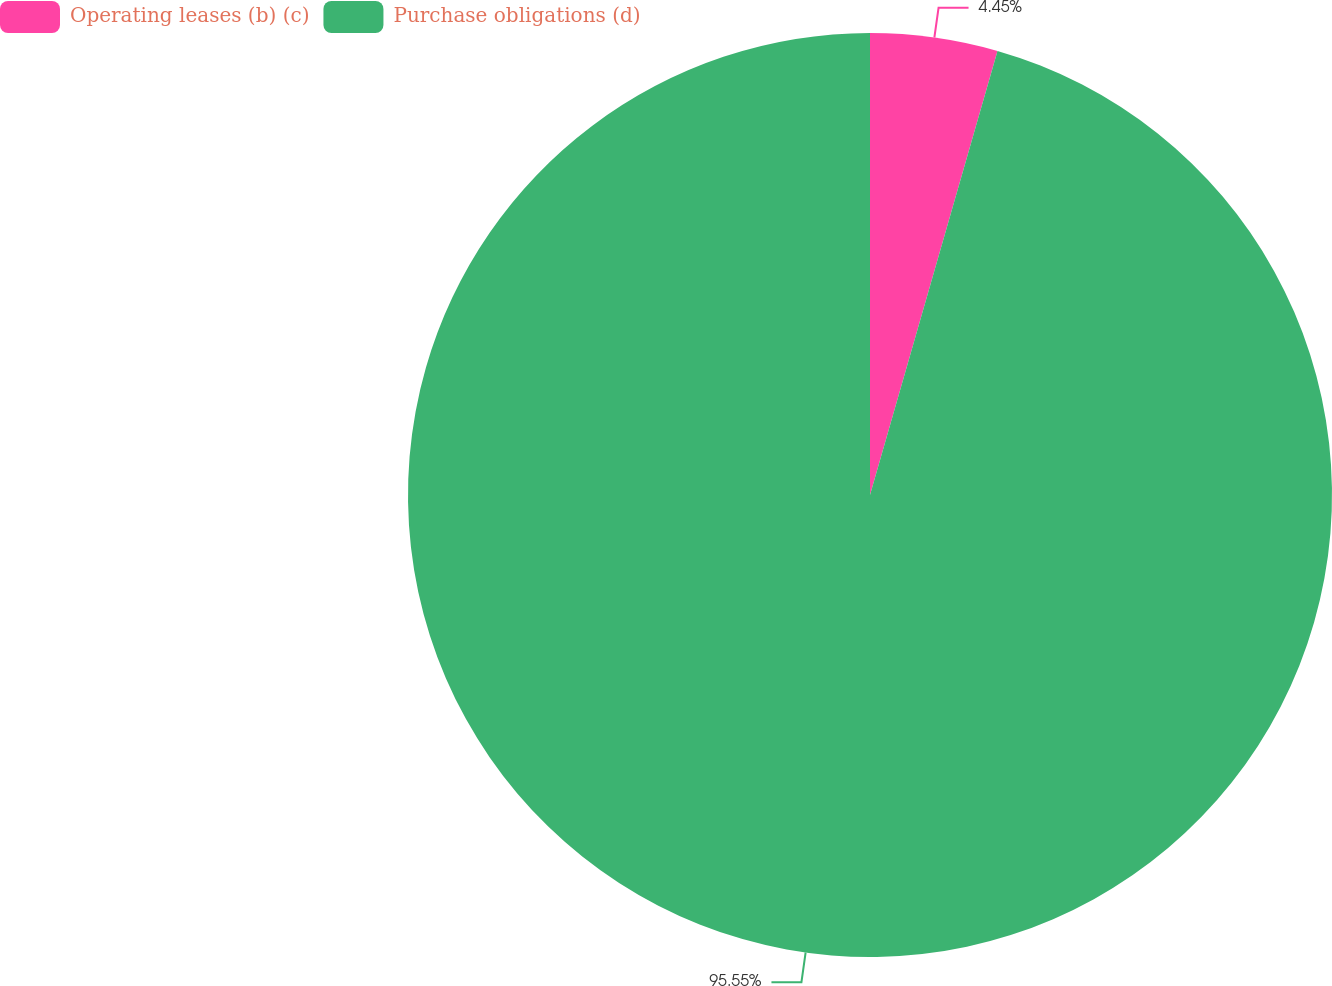<chart> <loc_0><loc_0><loc_500><loc_500><pie_chart><fcel>Operating leases (b) (c)<fcel>Purchase obligations (d)<nl><fcel>4.45%<fcel>95.55%<nl></chart> 